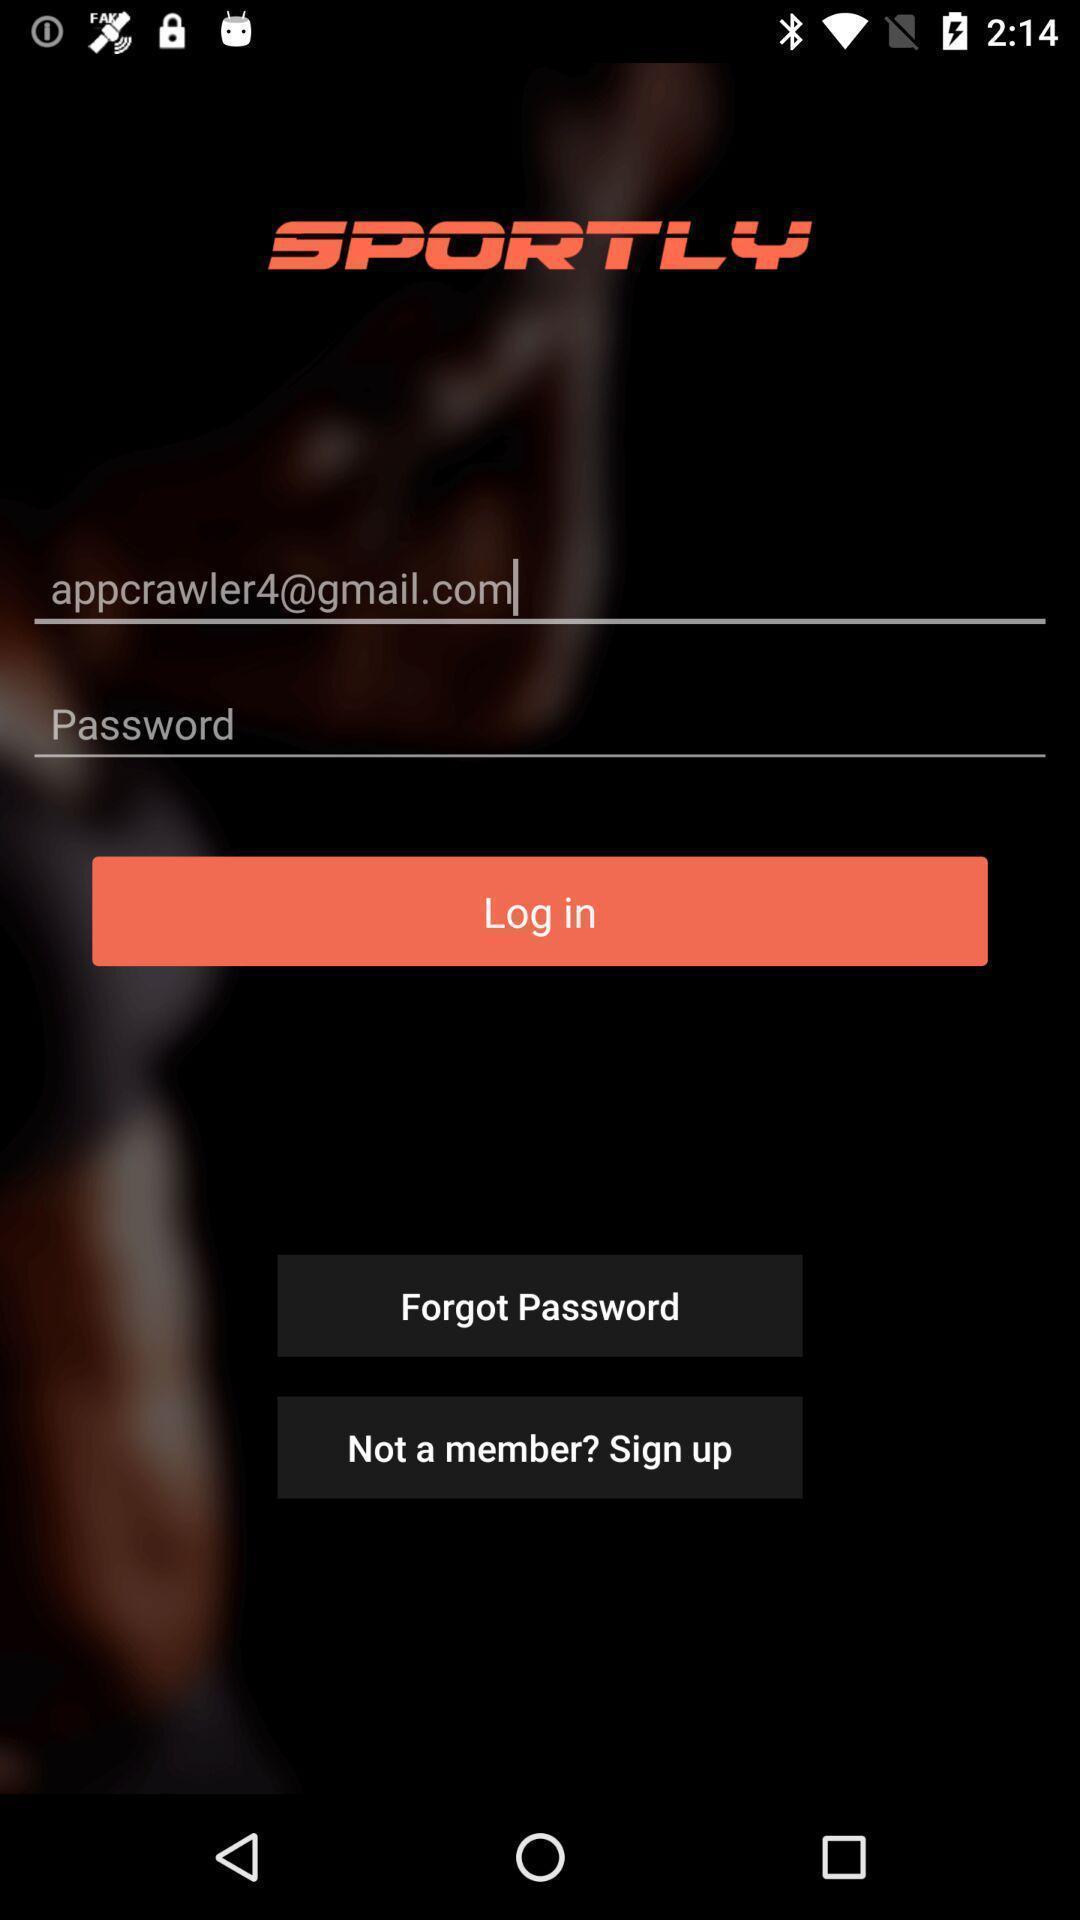Describe this image in words. Login page. 